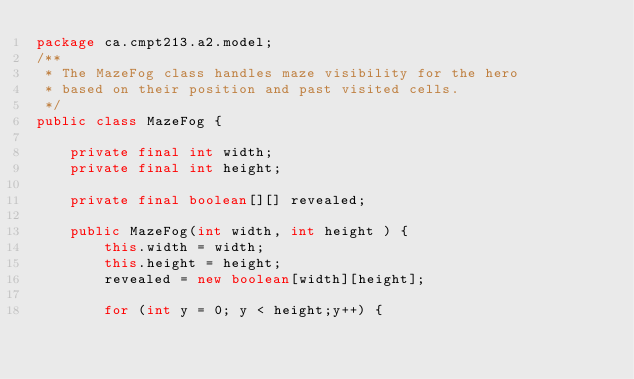Convert code to text. <code><loc_0><loc_0><loc_500><loc_500><_Java_>package ca.cmpt213.a2.model;
/**
 * The MazeFog class handles maze visibility for the hero
 * based on their position and past visited cells.
 */
public class MazeFog {

    private final int width;
    private final int height;

    private final boolean[][] revealed;

    public MazeFog(int width, int height ) {
        this.width = width;
        this.height = height;
        revealed = new boolean[width][height];

        for (int y = 0; y < height;y++) {</code> 